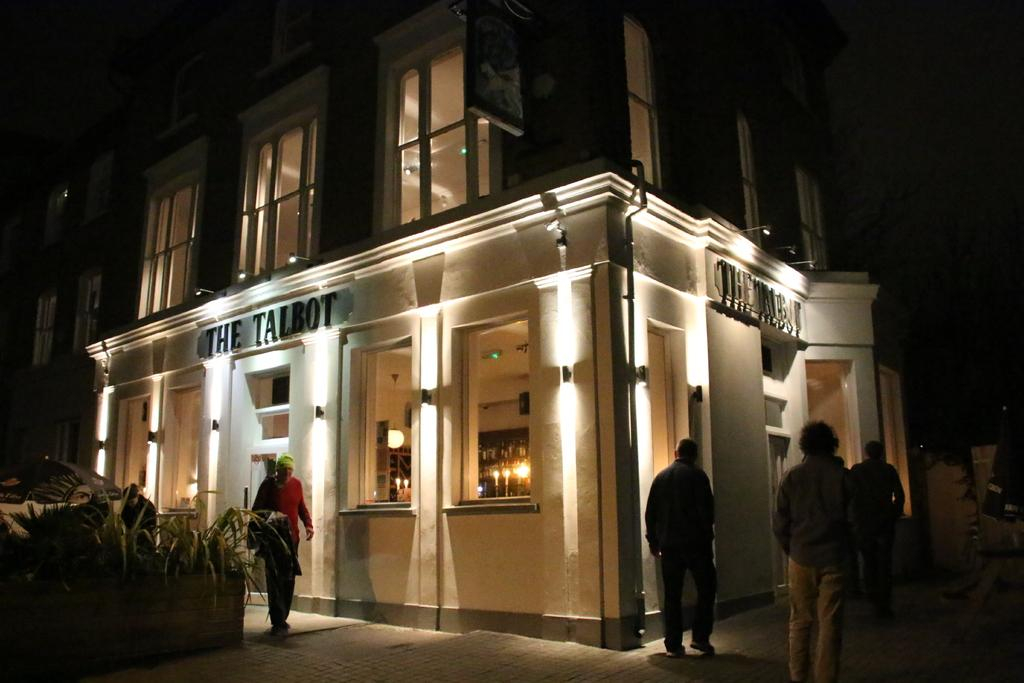What type of structure is visible in the image? There is a building in the image. Who or what else can be seen in the image? There are people and plants visible in the image. What type of toothpaste is being used by the people in the image? There is no toothpaste visible in the image, as it features a building, people, and plants. 